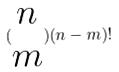<formula> <loc_0><loc_0><loc_500><loc_500>( \begin{matrix} n \\ m \end{matrix} ) ( n - m ) !</formula> 